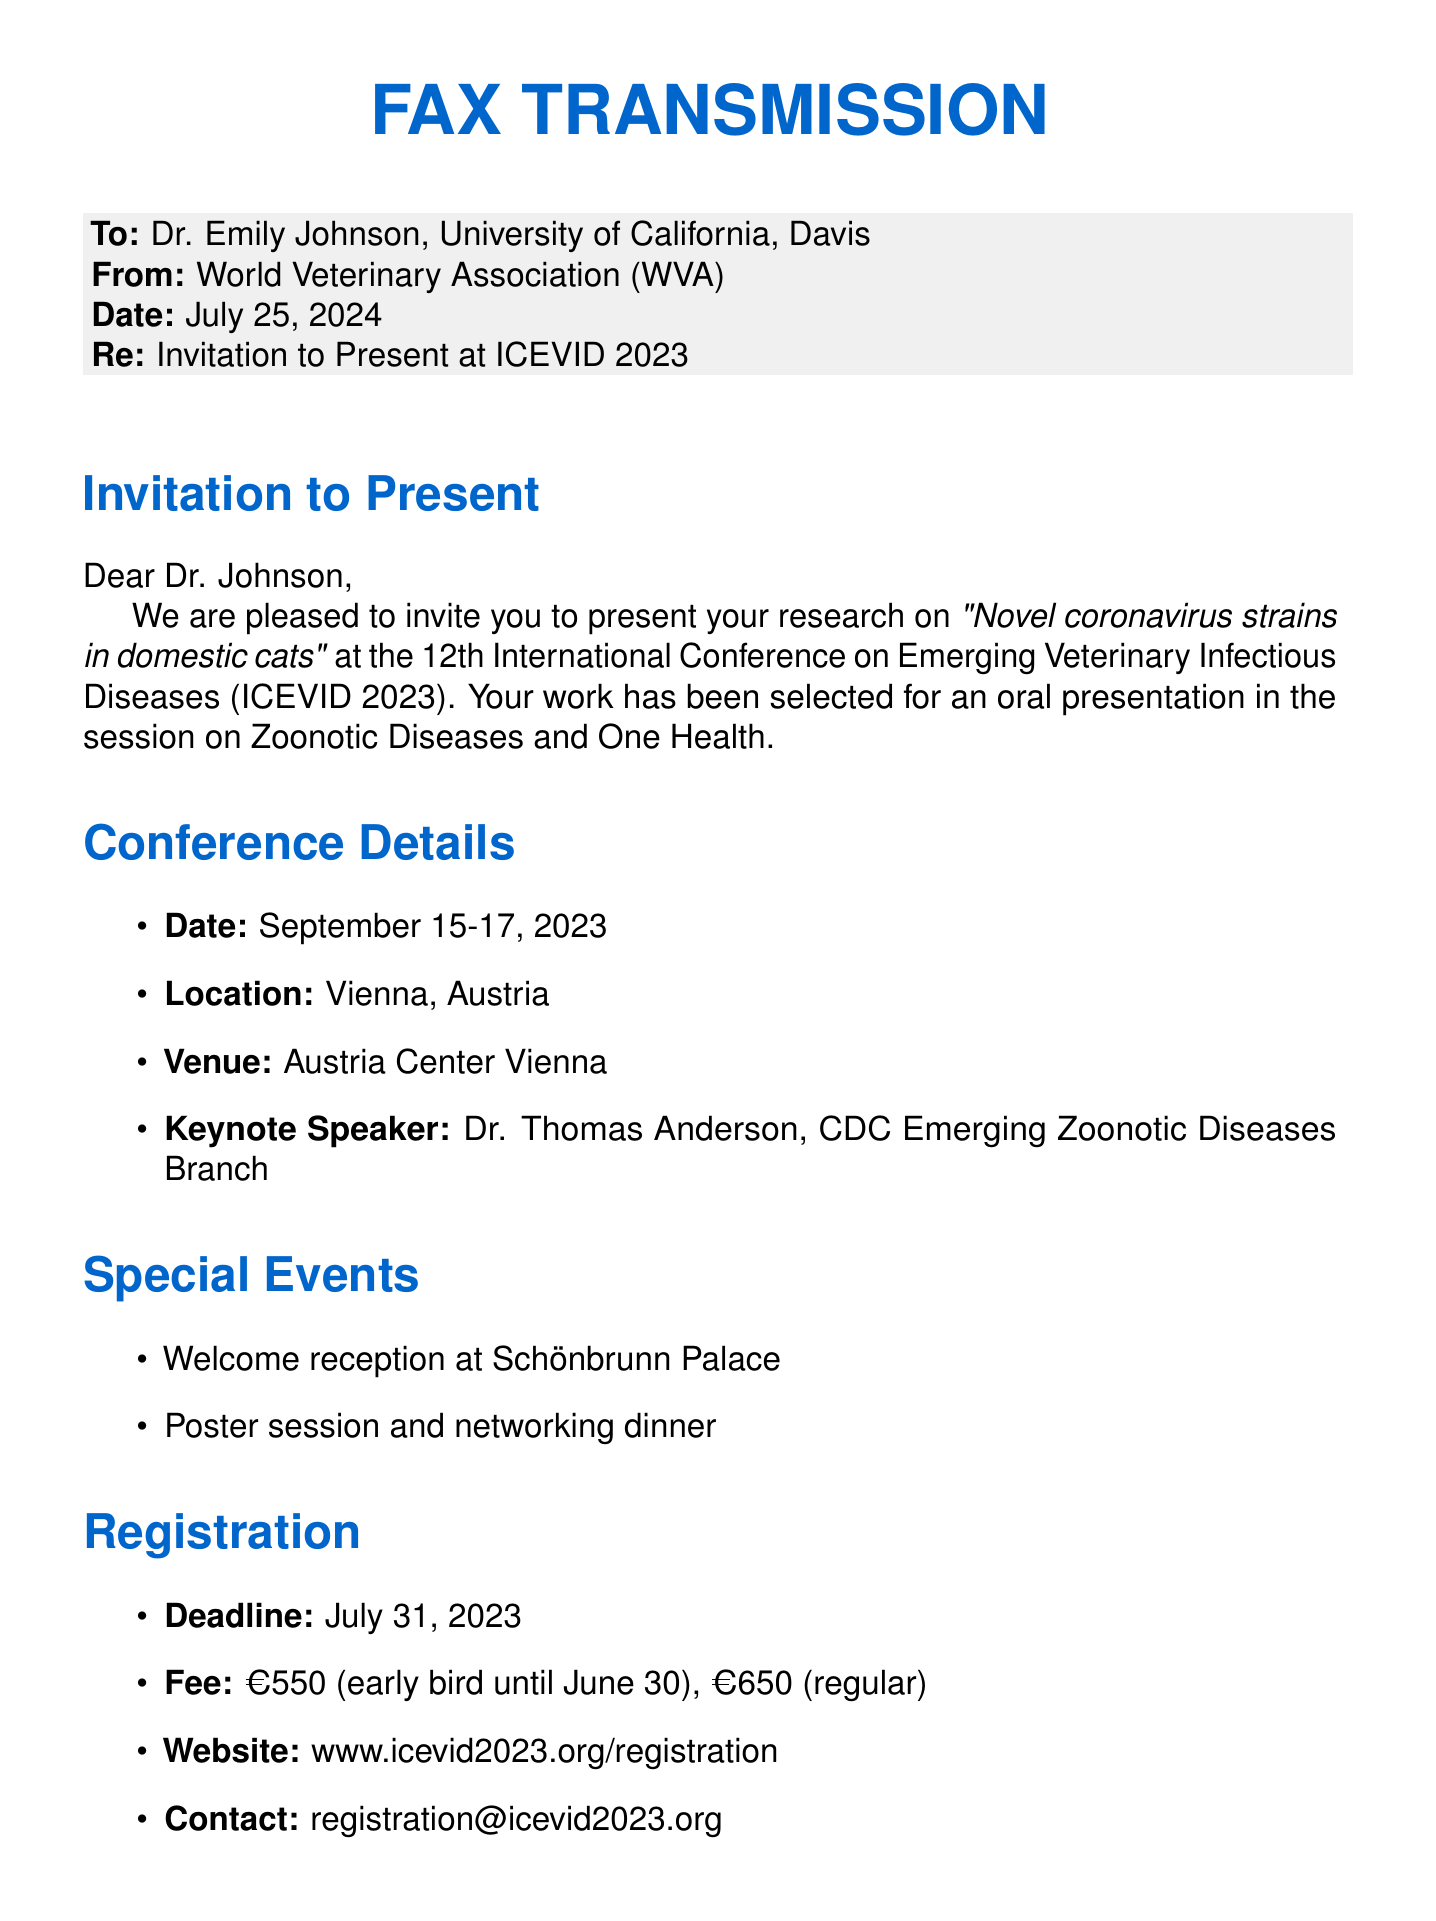What is the title of the presentation? The title of the presentation is stated in the invitation section, which mentions the research on "Novel coronavirus strains in domestic cats."
Answer: Novel coronavirus strains in domestic cats Who is the keynote speaker? The keynote speaker's name is mentioned in the conference details section, which lists Dr. Thomas Anderson.
Answer: Dr. Thomas Anderson What are the registration fees after June 30? The registration fees are specified in the registration section, indicating that the regular fee is €650.
Answer: €650 When is the abstract submission deadline? The abstract submission deadline is noted in the important dates section, which states it as May 31, 2023.
Answer: May 31, 2023 What city is the conference taking place in? The conference location is clearly mentioned under conference details, which states that it is in Vienna, Austria.
Answer: Vienna, Austria What special event is scheduled at Schönbrunn Palace? The special event listed in the document is the welcome reception, specifically noted in the special events section.
Answer: Welcome reception What is the deadline for early bird registration? This deadline is explicitly mentioned under the registration section, indicating that it is June 30, 2023.
Answer: June 30, 2023 What is the nearest airport to the conference venue? The nearest airport is identified in the travel information box, which specifies Vienna International Airport.
Answer: Vienna International Airport What is the venue for the conference? The venue information is provided in the conference details section, stating that the conference will take place at the Austria Center Vienna.
Answer: Austria Center Vienna 